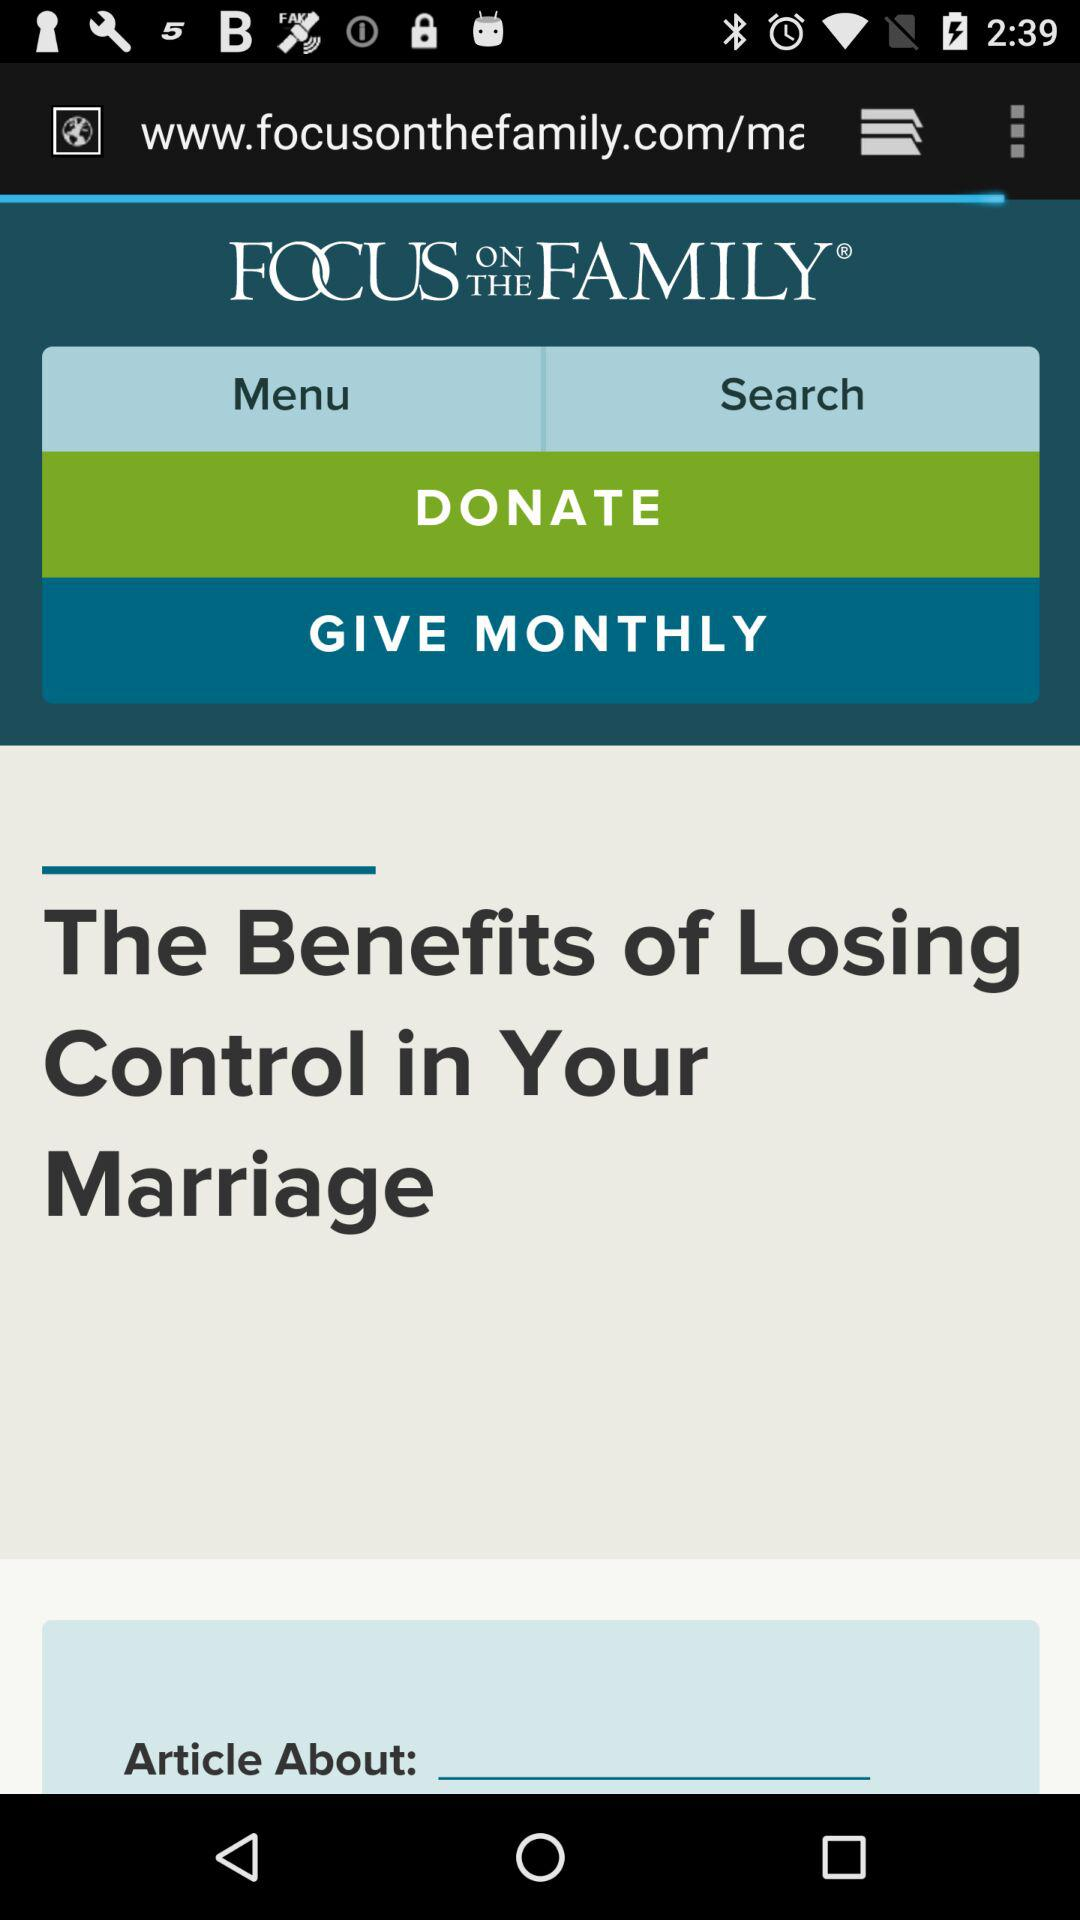What is the headline? The headline is "The Benefits of Losing Control in Your Marriage". 